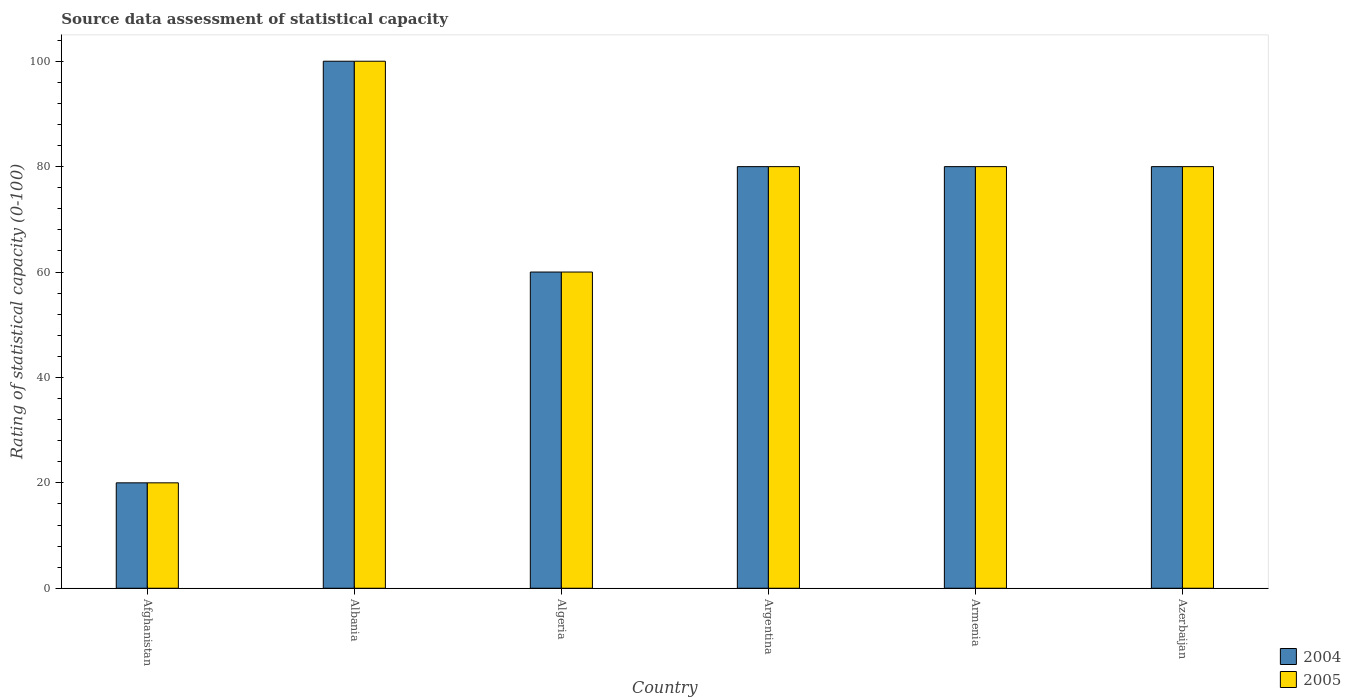How many different coloured bars are there?
Keep it short and to the point. 2. How many groups of bars are there?
Keep it short and to the point. 6. Are the number of bars on each tick of the X-axis equal?
Provide a succinct answer. Yes. How many bars are there on the 6th tick from the left?
Offer a terse response. 2. How many bars are there on the 6th tick from the right?
Provide a short and direct response. 2. What is the label of the 2nd group of bars from the left?
Provide a short and direct response. Albania. What is the rating of statistical capacity in 2004 in Albania?
Provide a short and direct response. 100. Across all countries, what is the maximum rating of statistical capacity in 2004?
Offer a very short reply. 100. Across all countries, what is the minimum rating of statistical capacity in 2005?
Provide a succinct answer. 20. In which country was the rating of statistical capacity in 2004 maximum?
Your answer should be compact. Albania. In which country was the rating of statistical capacity in 2004 minimum?
Make the answer very short. Afghanistan. What is the total rating of statistical capacity in 2004 in the graph?
Your answer should be very brief. 420. What is the difference between the rating of statistical capacity in 2005 in Argentina and that in Azerbaijan?
Your answer should be compact. 0. What is the average rating of statistical capacity in 2005 per country?
Offer a terse response. 70. What is the difference between the rating of statistical capacity of/in 2005 and rating of statistical capacity of/in 2004 in Albania?
Your answer should be very brief. 0. In how many countries, is the rating of statistical capacity in 2004 greater than 96?
Give a very brief answer. 1. What is the difference between the highest and the second highest rating of statistical capacity in 2004?
Provide a succinct answer. -20. What is the difference between the highest and the lowest rating of statistical capacity in 2004?
Your response must be concise. 80. In how many countries, is the rating of statistical capacity in 2004 greater than the average rating of statistical capacity in 2004 taken over all countries?
Make the answer very short. 4. What does the 2nd bar from the right in Argentina represents?
Provide a succinct answer. 2004. Are all the bars in the graph horizontal?
Your answer should be compact. No. What is the difference between two consecutive major ticks on the Y-axis?
Give a very brief answer. 20. Are the values on the major ticks of Y-axis written in scientific E-notation?
Keep it short and to the point. No. Does the graph contain any zero values?
Your answer should be compact. No. Does the graph contain grids?
Give a very brief answer. No. What is the title of the graph?
Provide a short and direct response. Source data assessment of statistical capacity. What is the label or title of the X-axis?
Your response must be concise. Country. What is the label or title of the Y-axis?
Your answer should be compact. Rating of statistical capacity (0-100). What is the Rating of statistical capacity (0-100) of 2004 in Albania?
Keep it short and to the point. 100. What is the Rating of statistical capacity (0-100) in 2004 in Argentina?
Offer a terse response. 80. What is the Rating of statistical capacity (0-100) of 2005 in Armenia?
Offer a very short reply. 80. Across all countries, what is the maximum Rating of statistical capacity (0-100) in 2005?
Make the answer very short. 100. What is the total Rating of statistical capacity (0-100) of 2004 in the graph?
Keep it short and to the point. 420. What is the total Rating of statistical capacity (0-100) in 2005 in the graph?
Provide a succinct answer. 420. What is the difference between the Rating of statistical capacity (0-100) of 2004 in Afghanistan and that in Albania?
Keep it short and to the point. -80. What is the difference between the Rating of statistical capacity (0-100) of 2005 in Afghanistan and that in Albania?
Your answer should be compact. -80. What is the difference between the Rating of statistical capacity (0-100) in 2004 in Afghanistan and that in Algeria?
Give a very brief answer. -40. What is the difference between the Rating of statistical capacity (0-100) in 2005 in Afghanistan and that in Algeria?
Offer a terse response. -40. What is the difference between the Rating of statistical capacity (0-100) in 2004 in Afghanistan and that in Argentina?
Your answer should be compact. -60. What is the difference between the Rating of statistical capacity (0-100) in 2005 in Afghanistan and that in Argentina?
Your response must be concise. -60. What is the difference between the Rating of statistical capacity (0-100) in 2004 in Afghanistan and that in Armenia?
Your answer should be compact. -60. What is the difference between the Rating of statistical capacity (0-100) of 2005 in Afghanistan and that in Armenia?
Your answer should be compact. -60. What is the difference between the Rating of statistical capacity (0-100) of 2004 in Afghanistan and that in Azerbaijan?
Your answer should be very brief. -60. What is the difference between the Rating of statistical capacity (0-100) of 2005 in Afghanistan and that in Azerbaijan?
Provide a short and direct response. -60. What is the difference between the Rating of statistical capacity (0-100) in 2004 in Albania and that in Algeria?
Your answer should be compact. 40. What is the difference between the Rating of statistical capacity (0-100) in 2005 in Albania and that in Algeria?
Offer a very short reply. 40. What is the difference between the Rating of statistical capacity (0-100) of 2004 in Albania and that in Argentina?
Make the answer very short. 20. What is the difference between the Rating of statistical capacity (0-100) of 2004 in Albania and that in Armenia?
Provide a short and direct response. 20. What is the difference between the Rating of statistical capacity (0-100) of 2005 in Albania and that in Azerbaijan?
Your answer should be very brief. 20. What is the difference between the Rating of statistical capacity (0-100) of 2005 in Algeria and that in Argentina?
Your response must be concise. -20. What is the difference between the Rating of statistical capacity (0-100) of 2004 in Algeria and that in Armenia?
Give a very brief answer. -20. What is the difference between the Rating of statistical capacity (0-100) of 2005 in Algeria and that in Armenia?
Provide a short and direct response. -20. What is the difference between the Rating of statistical capacity (0-100) of 2004 in Algeria and that in Azerbaijan?
Your answer should be very brief. -20. What is the difference between the Rating of statistical capacity (0-100) in 2005 in Algeria and that in Azerbaijan?
Offer a very short reply. -20. What is the difference between the Rating of statistical capacity (0-100) in 2004 in Argentina and that in Armenia?
Keep it short and to the point. 0. What is the difference between the Rating of statistical capacity (0-100) of 2004 in Armenia and that in Azerbaijan?
Ensure brevity in your answer.  0. What is the difference between the Rating of statistical capacity (0-100) of 2004 in Afghanistan and the Rating of statistical capacity (0-100) of 2005 in Albania?
Your answer should be very brief. -80. What is the difference between the Rating of statistical capacity (0-100) of 2004 in Afghanistan and the Rating of statistical capacity (0-100) of 2005 in Argentina?
Keep it short and to the point. -60. What is the difference between the Rating of statistical capacity (0-100) of 2004 in Afghanistan and the Rating of statistical capacity (0-100) of 2005 in Armenia?
Offer a very short reply. -60. What is the difference between the Rating of statistical capacity (0-100) of 2004 in Afghanistan and the Rating of statistical capacity (0-100) of 2005 in Azerbaijan?
Give a very brief answer. -60. What is the difference between the Rating of statistical capacity (0-100) in 2004 in Albania and the Rating of statistical capacity (0-100) in 2005 in Argentina?
Give a very brief answer. 20. What is the difference between the Rating of statistical capacity (0-100) of 2004 in Albania and the Rating of statistical capacity (0-100) of 2005 in Armenia?
Offer a terse response. 20. What is the difference between the Rating of statistical capacity (0-100) in 2004 in Algeria and the Rating of statistical capacity (0-100) in 2005 in Argentina?
Ensure brevity in your answer.  -20. What is the difference between the Rating of statistical capacity (0-100) in 2004 in Algeria and the Rating of statistical capacity (0-100) in 2005 in Armenia?
Make the answer very short. -20. What is the difference between the Rating of statistical capacity (0-100) in 2004 in Argentina and the Rating of statistical capacity (0-100) in 2005 in Armenia?
Give a very brief answer. 0. What is the difference between the Rating of statistical capacity (0-100) of 2004 and Rating of statistical capacity (0-100) of 2005 in Afghanistan?
Make the answer very short. 0. What is the difference between the Rating of statistical capacity (0-100) in 2004 and Rating of statistical capacity (0-100) in 2005 in Albania?
Give a very brief answer. 0. What is the difference between the Rating of statistical capacity (0-100) of 2004 and Rating of statistical capacity (0-100) of 2005 in Argentina?
Provide a succinct answer. 0. What is the difference between the Rating of statistical capacity (0-100) in 2004 and Rating of statistical capacity (0-100) in 2005 in Armenia?
Keep it short and to the point. 0. What is the difference between the Rating of statistical capacity (0-100) in 2004 and Rating of statistical capacity (0-100) in 2005 in Azerbaijan?
Ensure brevity in your answer.  0. What is the ratio of the Rating of statistical capacity (0-100) in 2005 in Afghanistan to that in Albania?
Your answer should be compact. 0.2. What is the ratio of the Rating of statistical capacity (0-100) of 2005 in Afghanistan to that in Algeria?
Provide a short and direct response. 0.33. What is the ratio of the Rating of statistical capacity (0-100) in 2004 in Afghanistan to that in Argentina?
Give a very brief answer. 0.25. What is the ratio of the Rating of statistical capacity (0-100) of 2005 in Afghanistan to that in Argentina?
Ensure brevity in your answer.  0.25. What is the ratio of the Rating of statistical capacity (0-100) of 2005 in Afghanistan to that in Armenia?
Offer a terse response. 0.25. What is the ratio of the Rating of statistical capacity (0-100) in 2005 in Afghanistan to that in Azerbaijan?
Give a very brief answer. 0.25. What is the ratio of the Rating of statistical capacity (0-100) of 2004 in Albania to that in Algeria?
Give a very brief answer. 1.67. What is the ratio of the Rating of statistical capacity (0-100) in 2005 in Albania to that in Argentina?
Ensure brevity in your answer.  1.25. What is the ratio of the Rating of statistical capacity (0-100) of 2005 in Albania to that in Armenia?
Give a very brief answer. 1.25. What is the ratio of the Rating of statistical capacity (0-100) of 2004 in Albania to that in Azerbaijan?
Keep it short and to the point. 1.25. What is the ratio of the Rating of statistical capacity (0-100) of 2004 in Algeria to that in Argentina?
Your answer should be compact. 0.75. What is the ratio of the Rating of statistical capacity (0-100) in 2004 in Algeria to that in Armenia?
Provide a succinct answer. 0.75. What is the ratio of the Rating of statistical capacity (0-100) in 2004 in Algeria to that in Azerbaijan?
Keep it short and to the point. 0.75. What is the ratio of the Rating of statistical capacity (0-100) in 2005 in Argentina to that in Azerbaijan?
Offer a very short reply. 1. What is the difference between the highest and the second highest Rating of statistical capacity (0-100) of 2004?
Your response must be concise. 20. What is the difference between the highest and the lowest Rating of statistical capacity (0-100) in 2004?
Ensure brevity in your answer.  80. 